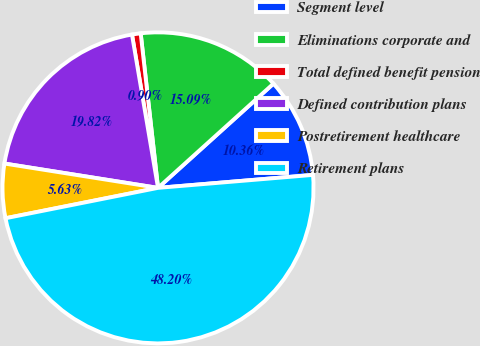Convert chart. <chart><loc_0><loc_0><loc_500><loc_500><pie_chart><fcel>Segment level<fcel>Eliminations corporate and<fcel>Total defined benefit pension<fcel>Defined contribution plans<fcel>Postretirement healthcare<fcel>Retirement plans<nl><fcel>10.36%<fcel>15.09%<fcel>0.9%<fcel>19.82%<fcel>5.63%<fcel>48.2%<nl></chart> 